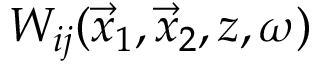Convert formula to latex. <formula><loc_0><loc_0><loc_500><loc_500>W _ { i j } ( \vec { x } _ { 1 } , \vec { x } _ { 2 } , z , \omega )</formula> 